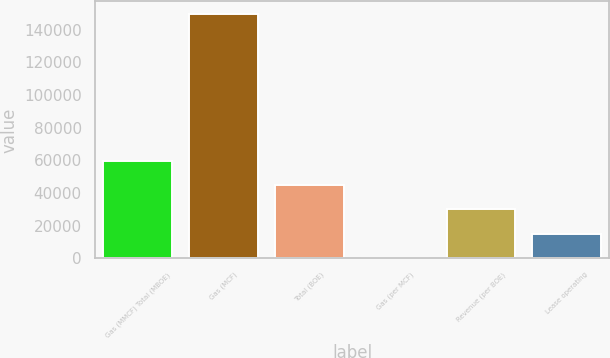Convert chart to OTSL. <chart><loc_0><loc_0><loc_500><loc_500><bar_chart><fcel>Gas (MMCF) Total (MBOE)<fcel>Gas (MCF)<fcel>Total (BOE)<fcel>Gas (per MCF)<fcel>Revenue (per BOE)<fcel>Lease operating<nl><fcel>59916.2<fcel>149787<fcel>44937.8<fcel>2.41<fcel>29959.3<fcel>14980.9<nl></chart> 